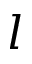<formula> <loc_0><loc_0><loc_500><loc_500>l</formula> 